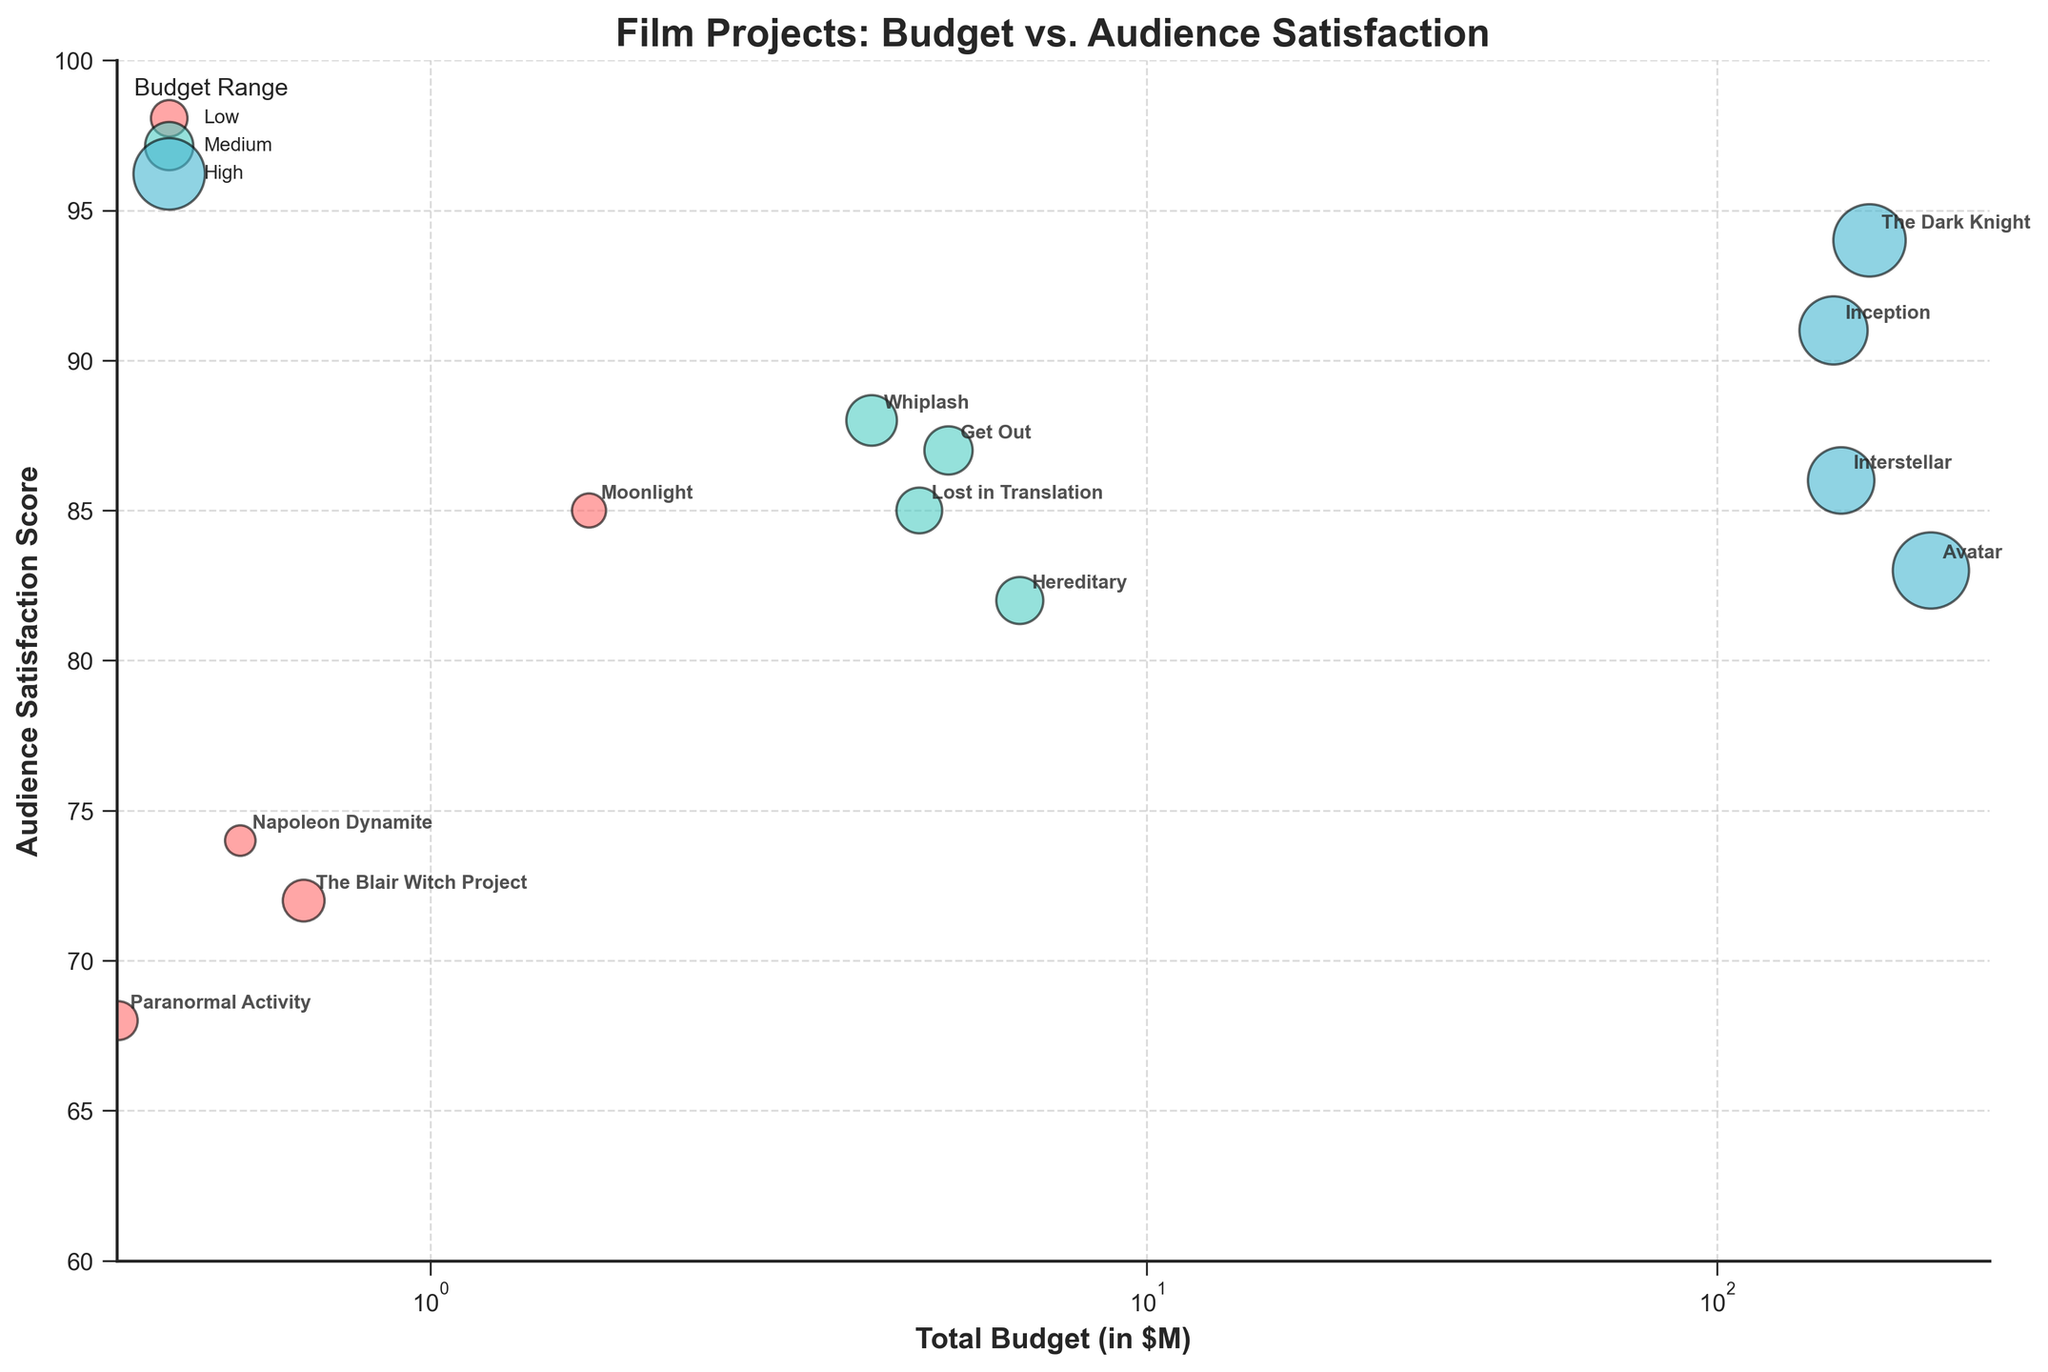What's the title of the figure? The title is prominently displayed at the top of the figure. It reads: "Film Projects: Budget vs. Audience Satisfaction".
Answer: Film Projects: Budget vs. Audience Satisfaction What are the axes labels? The x-axis label is "Total Budget (in $M)" and the y-axis label is "Audience Satisfaction Score".
Answer: Total Budget (in $M), Audience Satisfaction Score How many film projects are in the 'Low' budget range? The 'Low' budget range is represented by red bubbles. Counting these, we find the projects: 'Moonlight', 'The Blair Witch Project', 'Paranormal Activity', and 'Napoleon Dynamite'.
Answer: 4 Which film project has the highest Audience Satisfaction Score? Looking at the y-axis values and the bubble positions, 'The Dark Knight' has the highest Audience Satisfaction Score, which is 94.
Answer: The Dark Knight What is the total budget range for 'High' budget films? The budgets for 'High' films are: 'Inception' (160M), 'Avatar' (237M), 'The Dark Knight' (185M), and 'Interstellar' (165M). The range is from 160M to 237M.
Answer: 160M to 237M Which film project has the largest bubble? The bubble size represents the number of viewers. The largest bubble, indicating the highest number of viewers (50), belongs to 'Avatar'.
Answer: Avatar Among medium budget films, which has the lowest Audience Satisfaction Score? In the 'Medium' budget category, the film with the lowest y-axis value for Audience Satisfaction Score is 'Hereditary' with a score of 82.
Answer: Hereditary How does 'Whiplash' compare to 'Moonlight' in terms of Audience Satisfaction Score and budget? 'Whiplash' (Medium budget) has an Audience Satisfaction Score of 88 and a budget of 3.3M. 'Moonlight' (Low budget) has a score of 85 and a budget of 1.5M. 'Whiplash' has a higher satisfaction score and a larger budget.
Answer: Whiplash has a higher satisfaction score and a larger budget What is the difference in total budget between 'Inception' and 'Paranormal Activity'? 'Inception' has a budget of 160M and 'Paranormal Activity' has a budget of 0.015M. The difference in budget is 160 - 0.015 = 159.985M.
Answer: 159.985M Do films with higher budgets tend to have higher Audience Satisfaction Scores in general? Observing the chart, higher budget films (blue bubbles) tend to be positioned higher on the y-axis, indicating higher satisfaction scores, compared to medium (green) and low (red) budget films. However, some high-budget films like 'Avatar' have slightly lower scores than some medium-budget films like 'Whiplash'.
Answer: Yes, generally but with some exceptions 